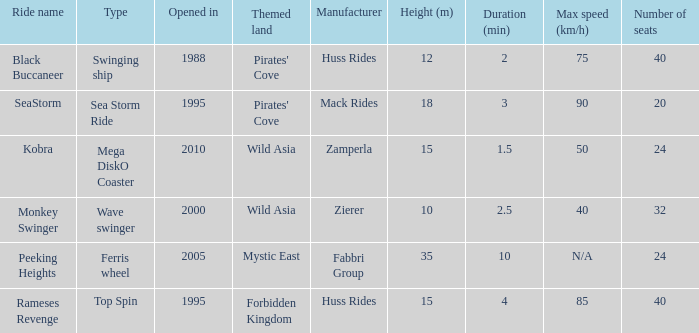Which ride opened after the 2000 Peeking Heights? Ferris wheel. Could you help me parse every detail presented in this table? {'header': ['Ride name', 'Type', 'Opened in', 'Themed land', 'Manufacturer', 'Height (m)', 'Duration (min)', 'Max speed (km/h)', 'Number of seats'], 'rows': [['Black Buccaneer', 'Swinging ship', '1988', "Pirates' Cove", 'Huss Rides', '12', '2', '75', '40'], ['SeaStorm', 'Sea Storm Ride', '1995', "Pirates' Cove", 'Mack Rides', '18', '3', '90', '20'], ['Kobra', 'Mega DiskO Coaster', '2010', 'Wild Asia', 'Zamperla', '15', '1.5', '50', '24'], ['Monkey Swinger', 'Wave swinger', '2000', 'Wild Asia', 'Zierer', '10', '2.5', '40', '32'], ['Peeking Heights', 'Ferris wheel', '2005', 'Mystic East', 'Fabbri Group', '35', '10', 'N/A', '24'], ['Rameses Revenge', 'Top Spin', '1995', 'Forbidden Kingdom', 'Huss Rides', '15', '4', '85', '40']]} 